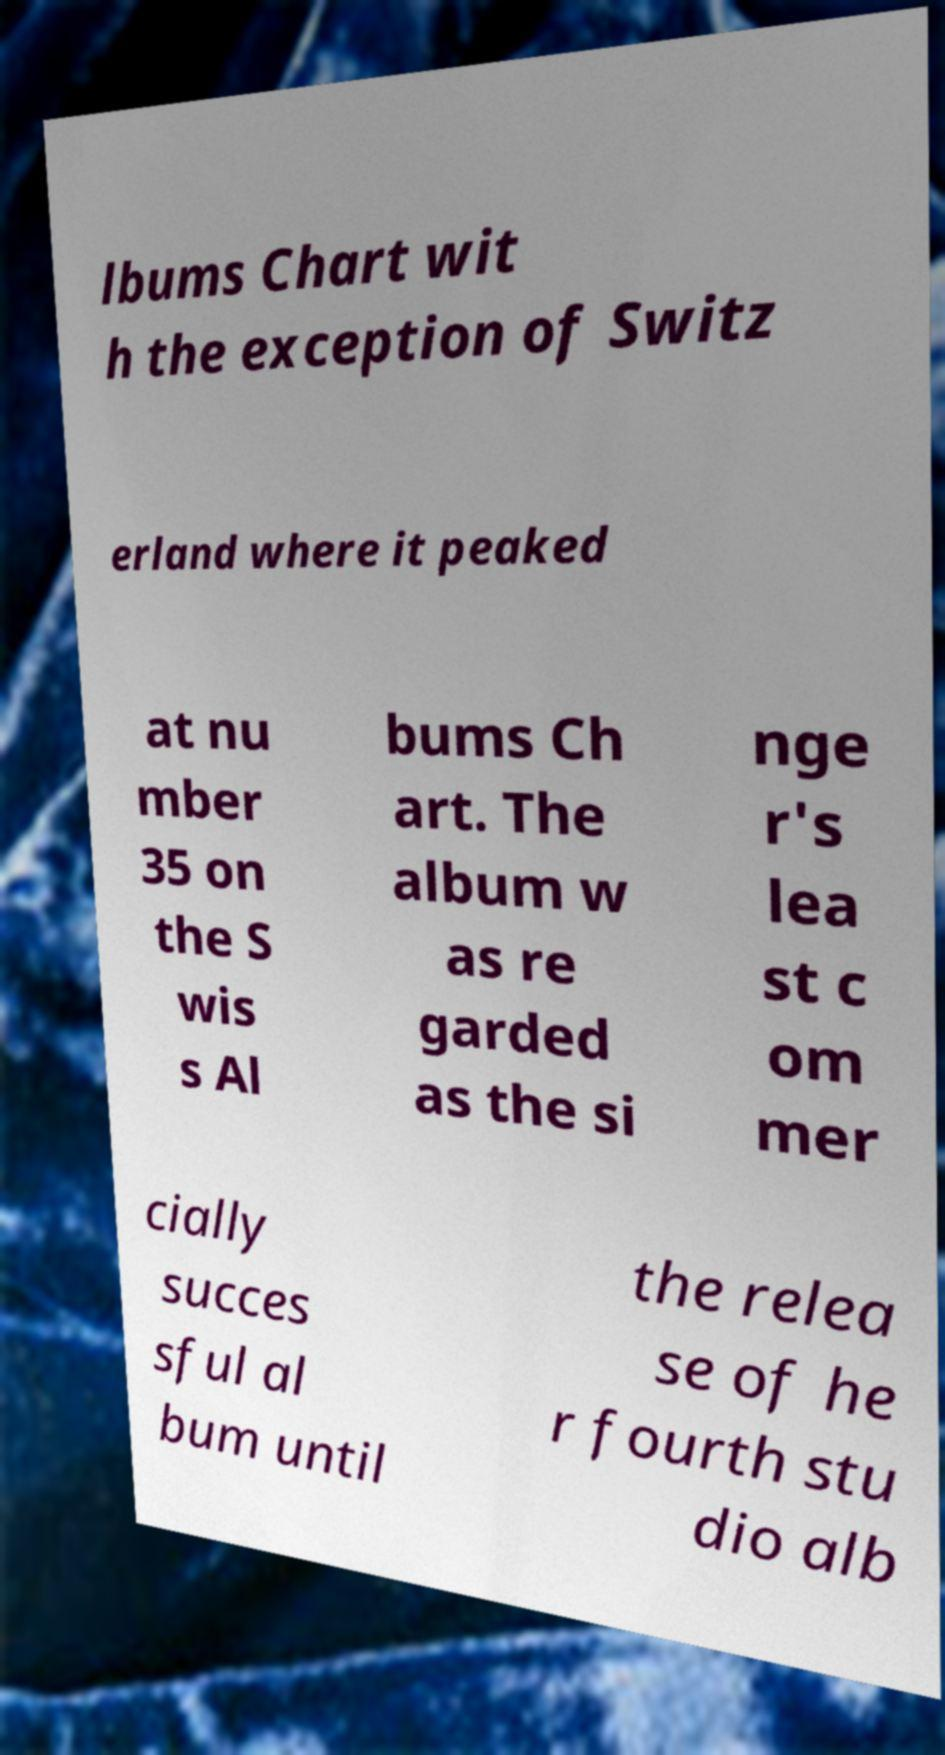I need the written content from this picture converted into text. Can you do that? lbums Chart wit h the exception of Switz erland where it peaked at nu mber 35 on the S wis s Al bums Ch art. The album w as re garded as the si nge r's lea st c om mer cially succes sful al bum until the relea se of he r fourth stu dio alb 